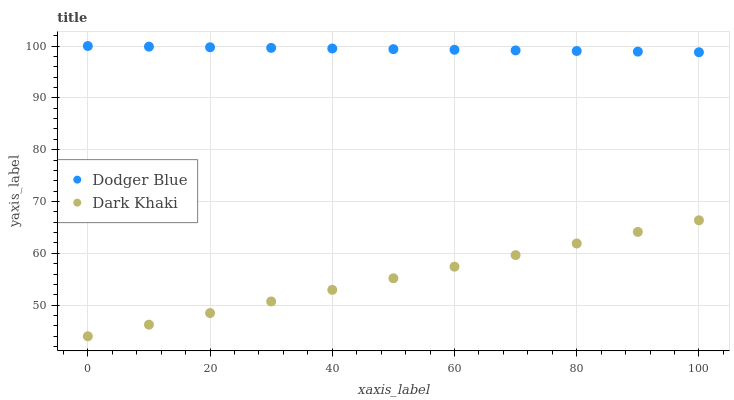Does Dark Khaki have the minimum area under the curve?
Answer yes or no. Yes. Does Dodger Blue have the maximum area under the curve?
Answer yes or no. Yes. Does Dodger Blue have the minimum area under the curve?
Answer yes or no. No. Is Dark Khaki the smoothest?
Answer yes or no. Yes. Is Dodger Blue the roughest?
Answer yes or no. Yes. Is Dodger Blue the smoothest?
Answer yes or no. No. Does Dark Khaki have the lowest value?
Answer yes or no. Yes. Does Dodger Blue have the lowest value?
Answer yes or no. No. Does Dodger Blue have the highest value?
Answer yes or no. Yes. Is Dark Khaki less than Dodger Blue?
Answer yes or no. Yes. Is Dodger Blue greater than Dark Khaki?
Answer yes or no. Yes. Does Dark Khaki intersect Dodger Blue?
Answer yes or no. No. 